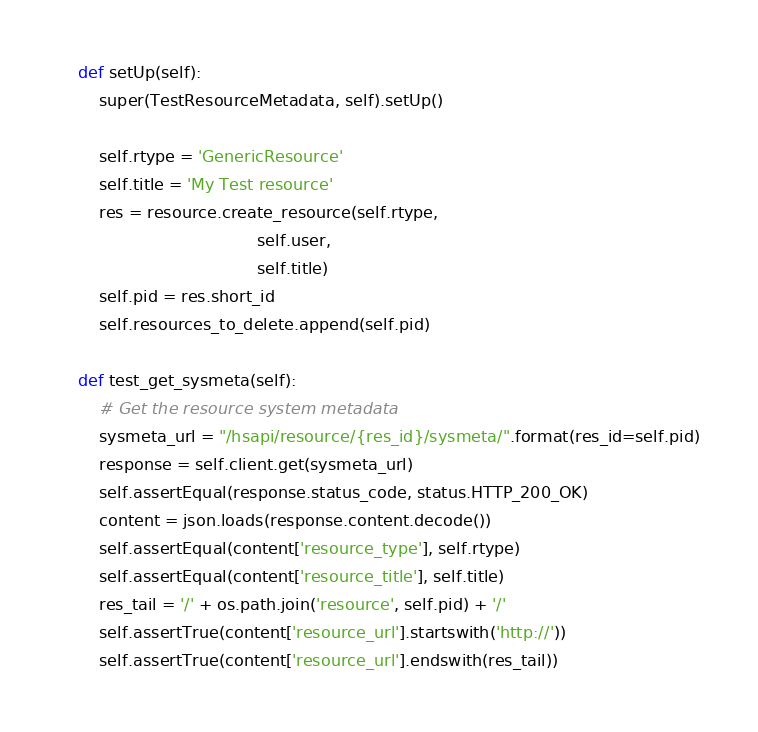Convert code to text. <code><loc_0><loc_0><loc_500><loc_500><_Python_>
    def setUp(self):
        super(TestResourceMetadata, self).setUp()

        self.rtype = 'GenericResource'
        self.title = 'My Test resource'
        res = resource.create_resource(self.rtype,
                                       self.user,
                                       self.title)
        self.pid = res.short_id
        self.resources_to_delete.append(self.pid)

    def test_get_sysmeta(self):
        # Get the resource system metadata
        sysmeta_url = "/hsapi/resource/{res_id}/sysmeta/".format(res_id=self.pid)
        response = self.client.get(sysmeta_url)
        self.assertEqual(response.status_code, status.HTTP_200_OK)
        content = json.loads(response.content.decode())
        self.assertEqual(content['resource_type'], self.rtype)
        self.assertEqual(content['resource_title'], self.title)
        res_tail = '/' + os.path.join('resource', self.pid) + '/'
        self.assertTrue(content['resource_url'].startswith('http://'))
        self.assertTrue(content['resource_url'].endswith(res_tail))
</code> 